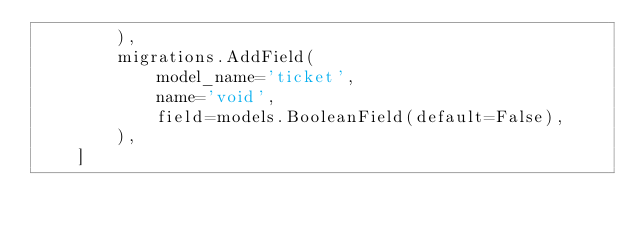<code> <loc_0><loc_0><loc_500><loc_500><_Python_>        ),
        migrations.AddField(
            model_name='ticket',
            name='void',
            field=models.BooleanField(default=False),
        ),
    ]
</code> 